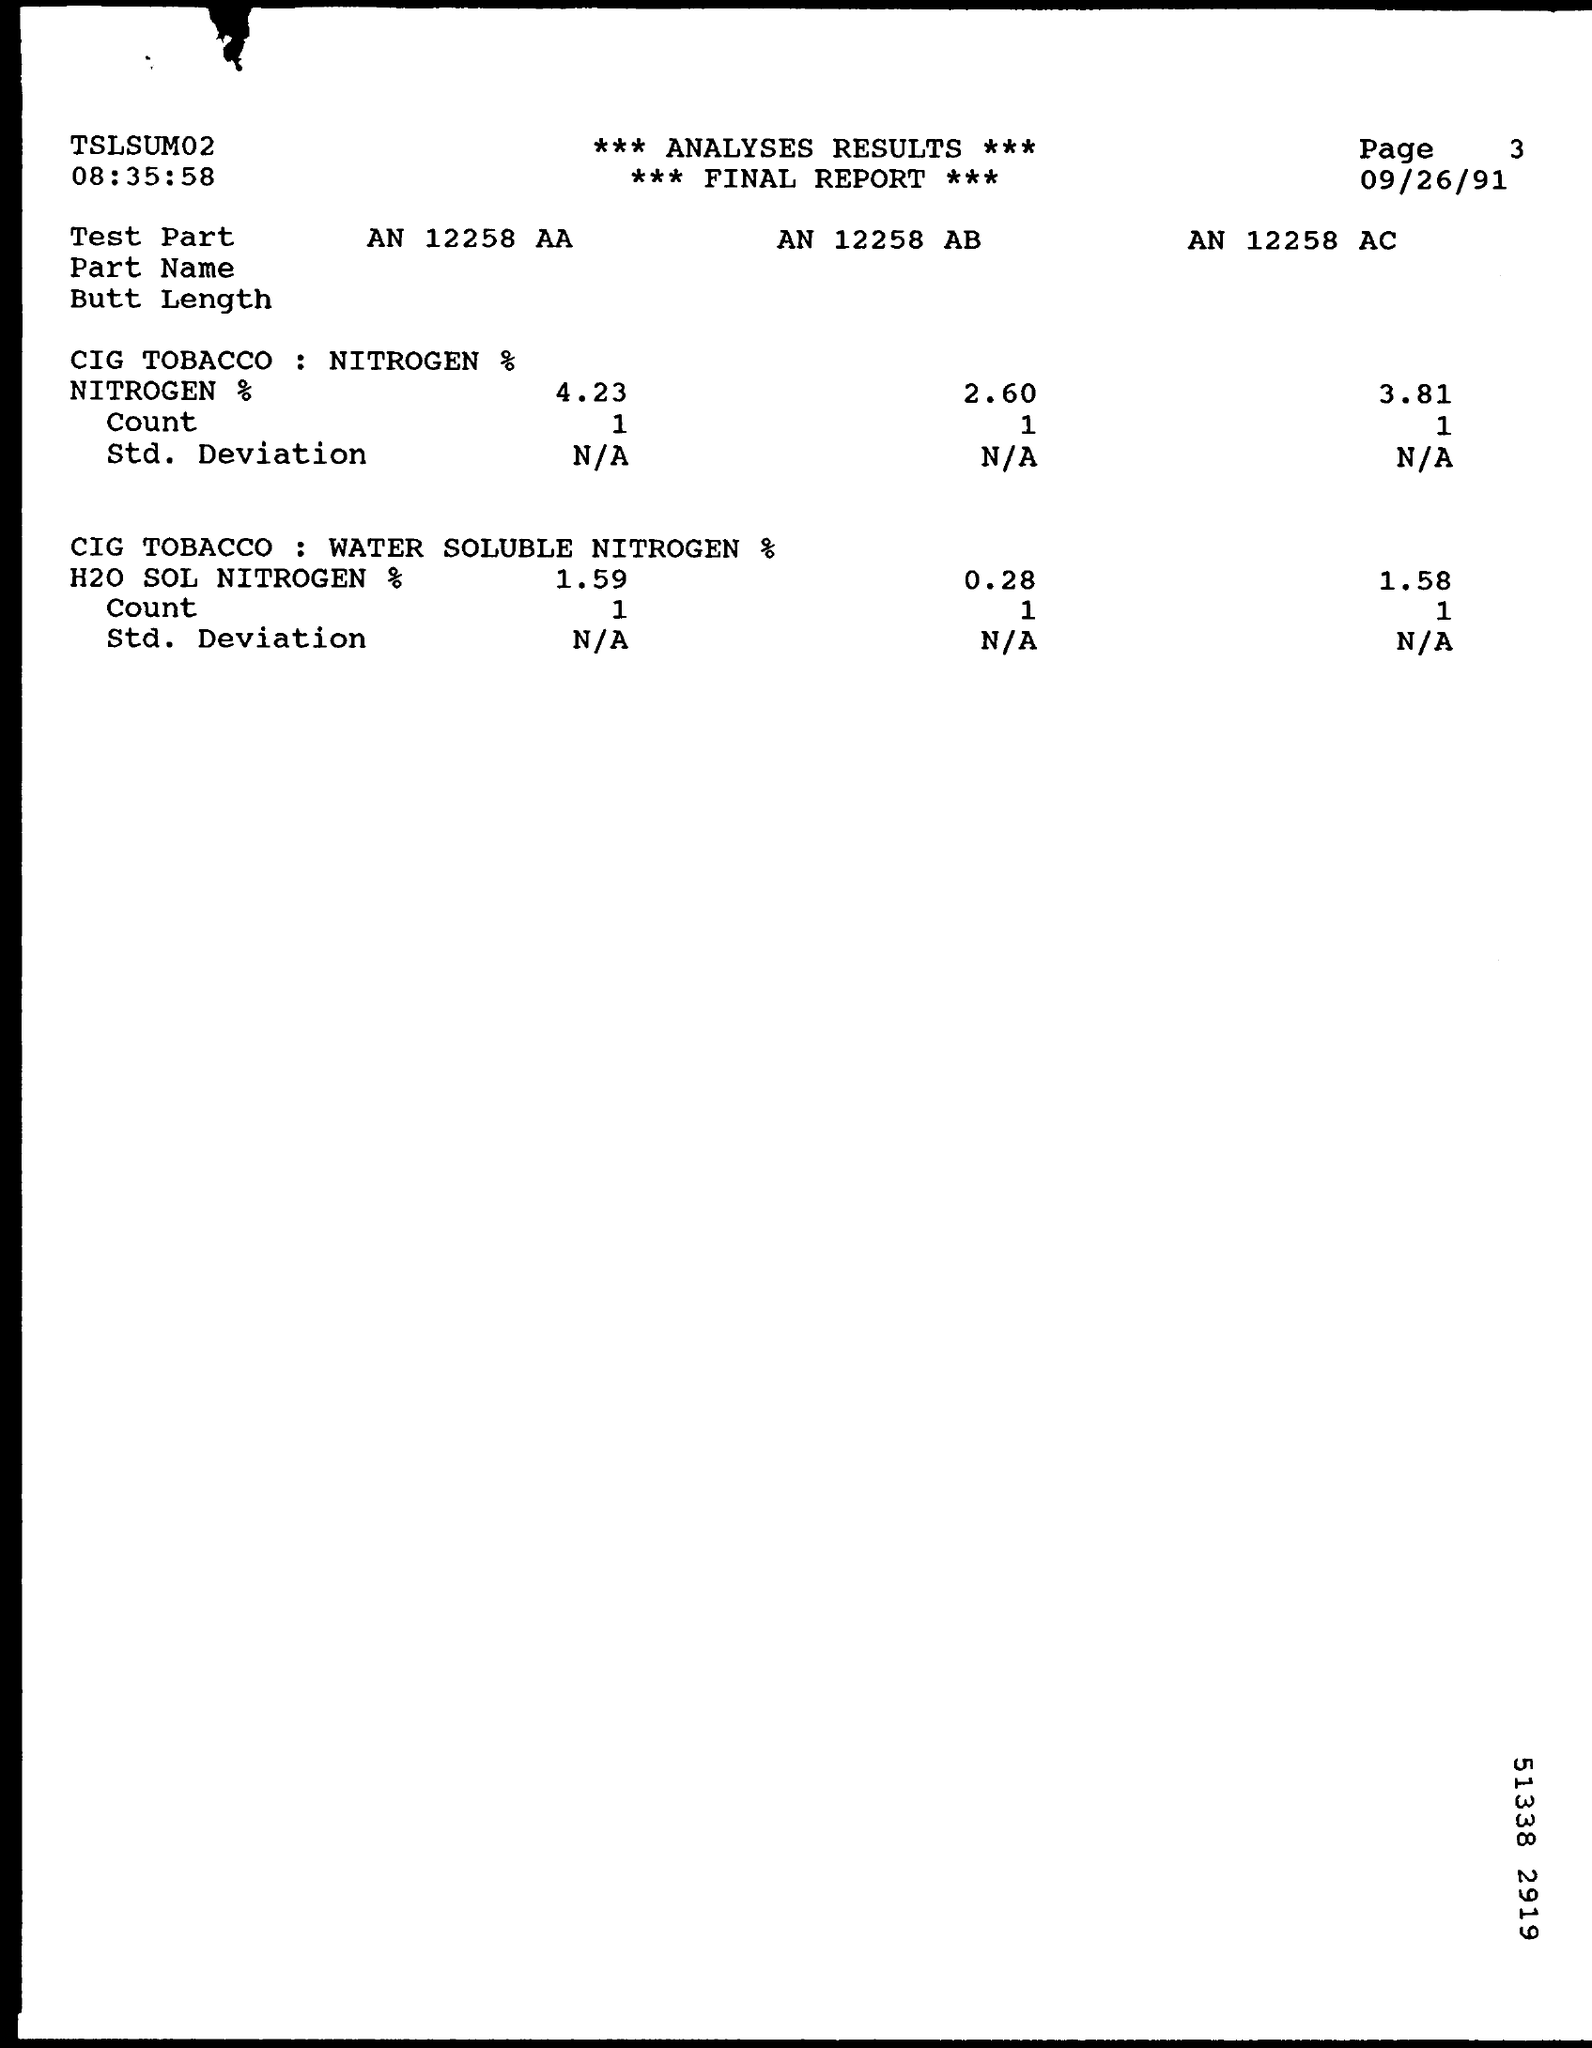Draw attention to some important aspects in this diagram. The value of the count in the test part AN 12258 AA containing nitrogen is 1. The date mentioned in the final report is September 26, 1991. 